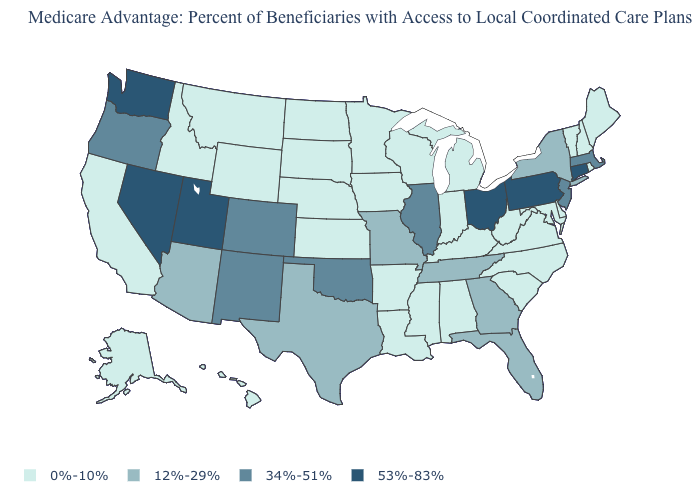What is the highest value in the USA?
Keep it brief. 53%-83%. What is the lowest value in the USA?
Keep it brief. 0%-10%. Which states have the lowest value in the MidWest?
Write a very short answer. Iowa, Indiana, Kansas, Michigan, Minnesota, North Dakota, Nebraska, South Dakota, Wisconsin. What is the value of Colorado?
Quick response, please. 34%-51%. Which states have the highest value in the USA?
Answer briefly. Connecticut, Nevada, Ohio, Pennsylvania, Utah, Washington. What is the value of Indiana?
Be succinct. 0%-10%. What is the lowest value in the USA?
Be succinct. 0%-10%. Among the states that border Delaware , which have the highest value?
Concise answer only. Pennsylvania. How many symbols are there in the legend?
Short answer required. 4. Among the states that border Florida , which have the lowest value?
Quick response, please. Alabama. Among the states that border Nebraska , does Colorado have the highest value?
Concise answer only. Yes. Which states hav the highest value in the West?
Quick response, please. Nevada, Utah, Washington. Among the states that border Louisiana , does Mississippi have the lowest value?
Keep it brief. Yes. Is the legend a continuous bar?
Give a very brief answer. No. What is the value of Oklahoma?
Give a very brief answer. 34%-51%. 